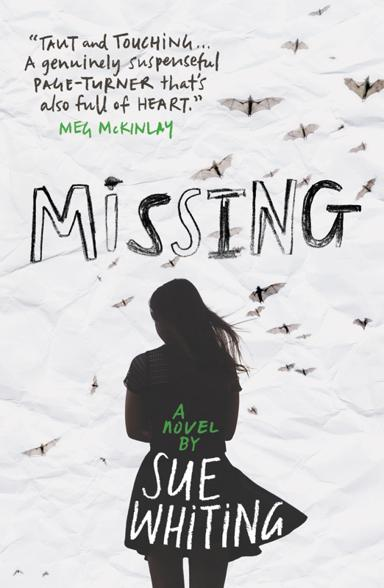What themes might be explored in the novel based on the cover art? Judging by the book's title, 'Missing,' and the visual elements on the cover, the novel likely delves into themes of disappearance and the emotional ramifications of loss. The presence of numerous butterflies might suggest themes of transformation, hope, and the fragility of life. These visual cues indicate that the narrative might explore the complexities of personal growth after a significant loss, the search for truth, and the impact of absence on the human soul. 